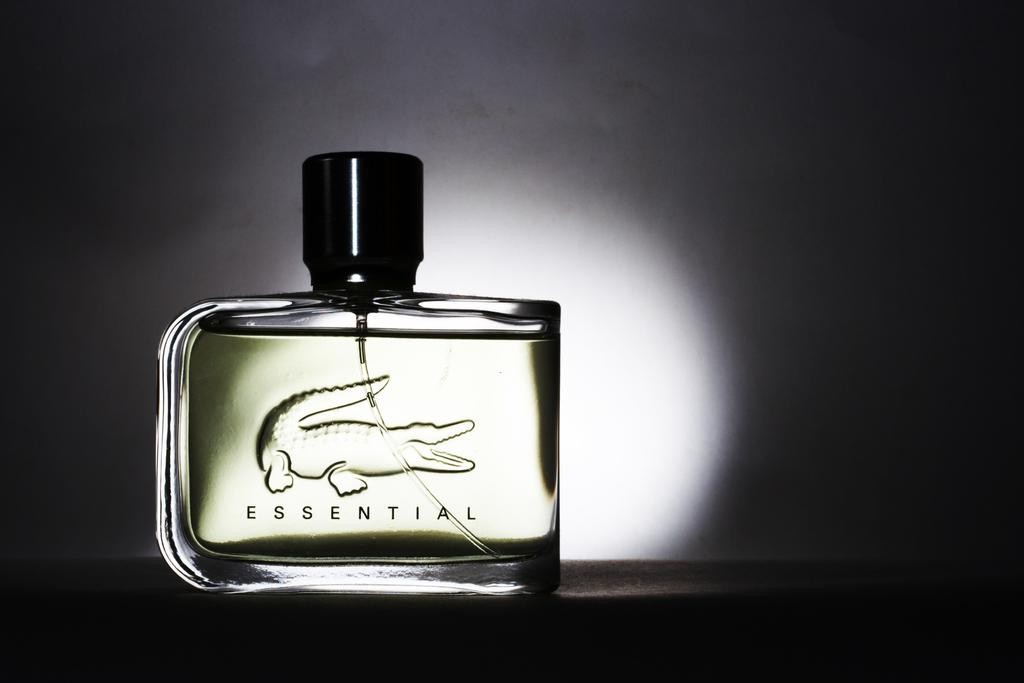<image>
Render a clear and concise summary of the photo. A bottle of men's cologne called Essential with a crocodile on it 